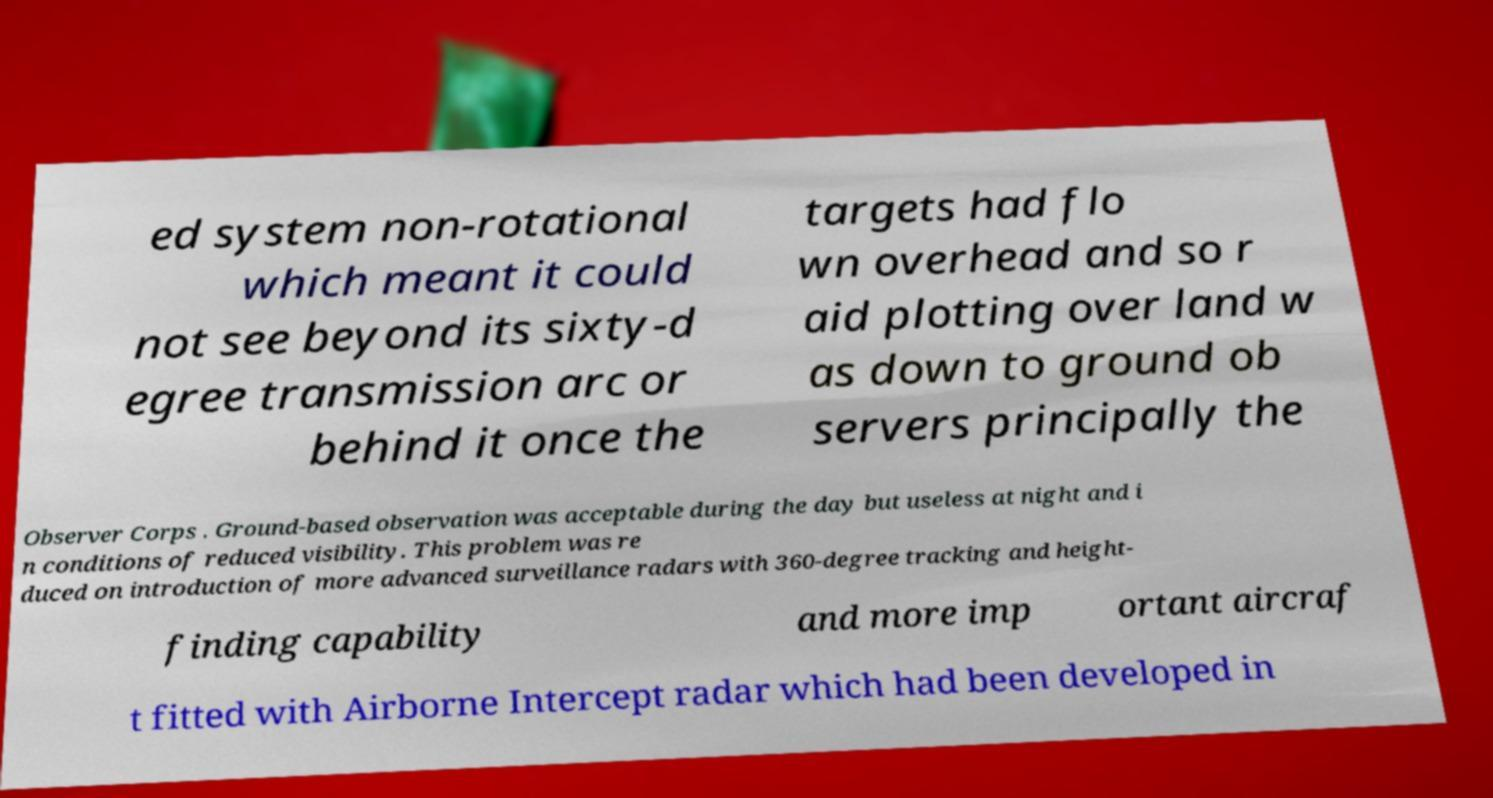Can you accurately transcribe the text from the provided image for me? ed system non-rotational which meant it could not see beyond its sixty-d egree transmission arc or behind it once the targets had flo wn overhead and so r aid plotting over land w as down to ground ob servers principally the Observer Corps . Ground-based observation was acceptable during the day but useless at night and i n conditions of reduced visibility. This problem was re duced on introduction of more advanced surveillance radars with 360-degree tracking and height- finding capability and more imp ortant aircraf t fitted with Airborne Intercept radar which had been developed in 